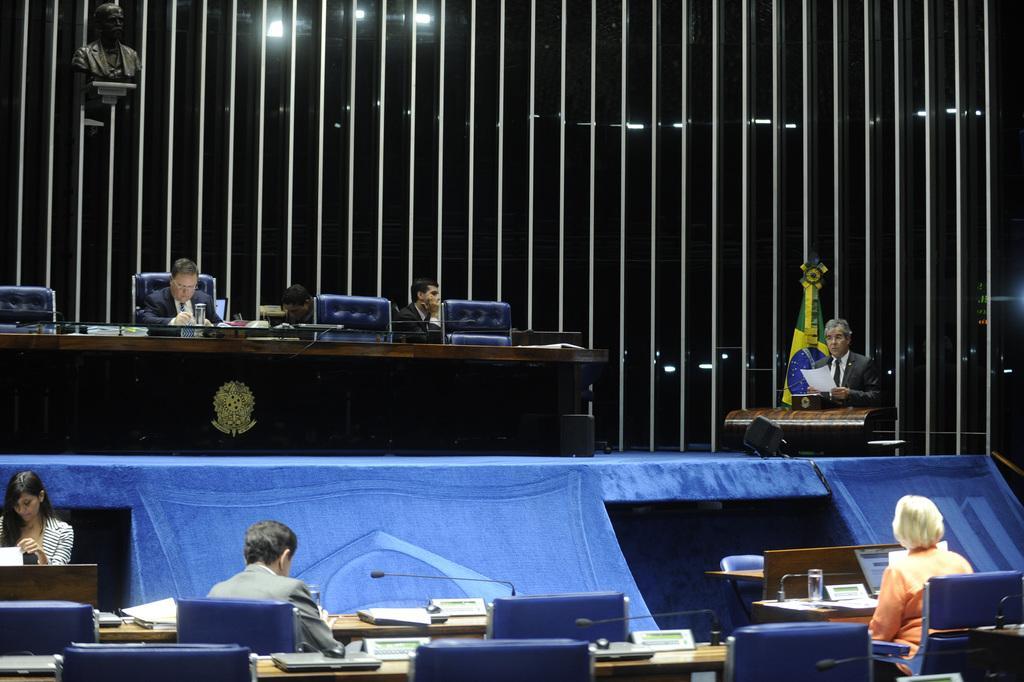Can you describe this image briefly? This picture shows a meeting hall were we see people seated on the chairs and we see a microphone 